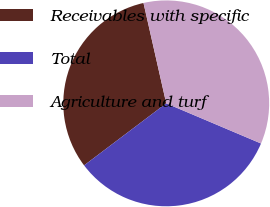<chart> <loc_0><loc_0><loc_500><loc_500><pie_chart><fcel>Receivables with specific<fcel>Total<fcel>Agriculture and turf<nl><fcel>31.75%<fcel>33.33%<fcel>34.92%<nl></chart> 